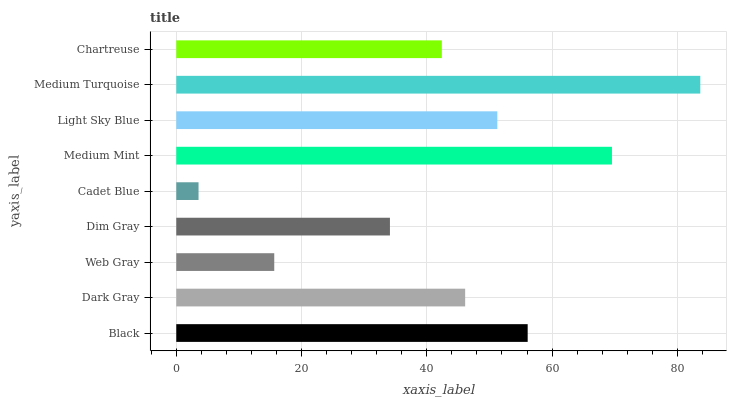Is Cadet Blue the minimum?
Answer yes or no. Yes. Is Medium Turquoise the maximum?
Answer yes or no. Yes. Is Dark Gray the minimum?
Answer yes or no. No. Is Dark Gray the maximum?
Answer yes or no. No. Is Black greater than Dark Gray?
Answer yes or no. Yes. Is Dark Gray less than Black?
Answer yes or no. Yes. Is Dark Gray greater than Black?
Answer yes or no. No. Is Black less than Dark Gray?
Answer yes or no. No. Is Dark Gray the high median?
Answer yes or no. Yes. Is Dark Gray the low median?
Answer yes or no. Yes. Is Chartreuse the high median?
Answer yes or no. No. Is Chartreuse the low median?
Answer yes or no. No. 